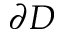Convert formula to latex. <formula><loc_0><loc_0><loc_500><loc_500>\partial D</formula> 